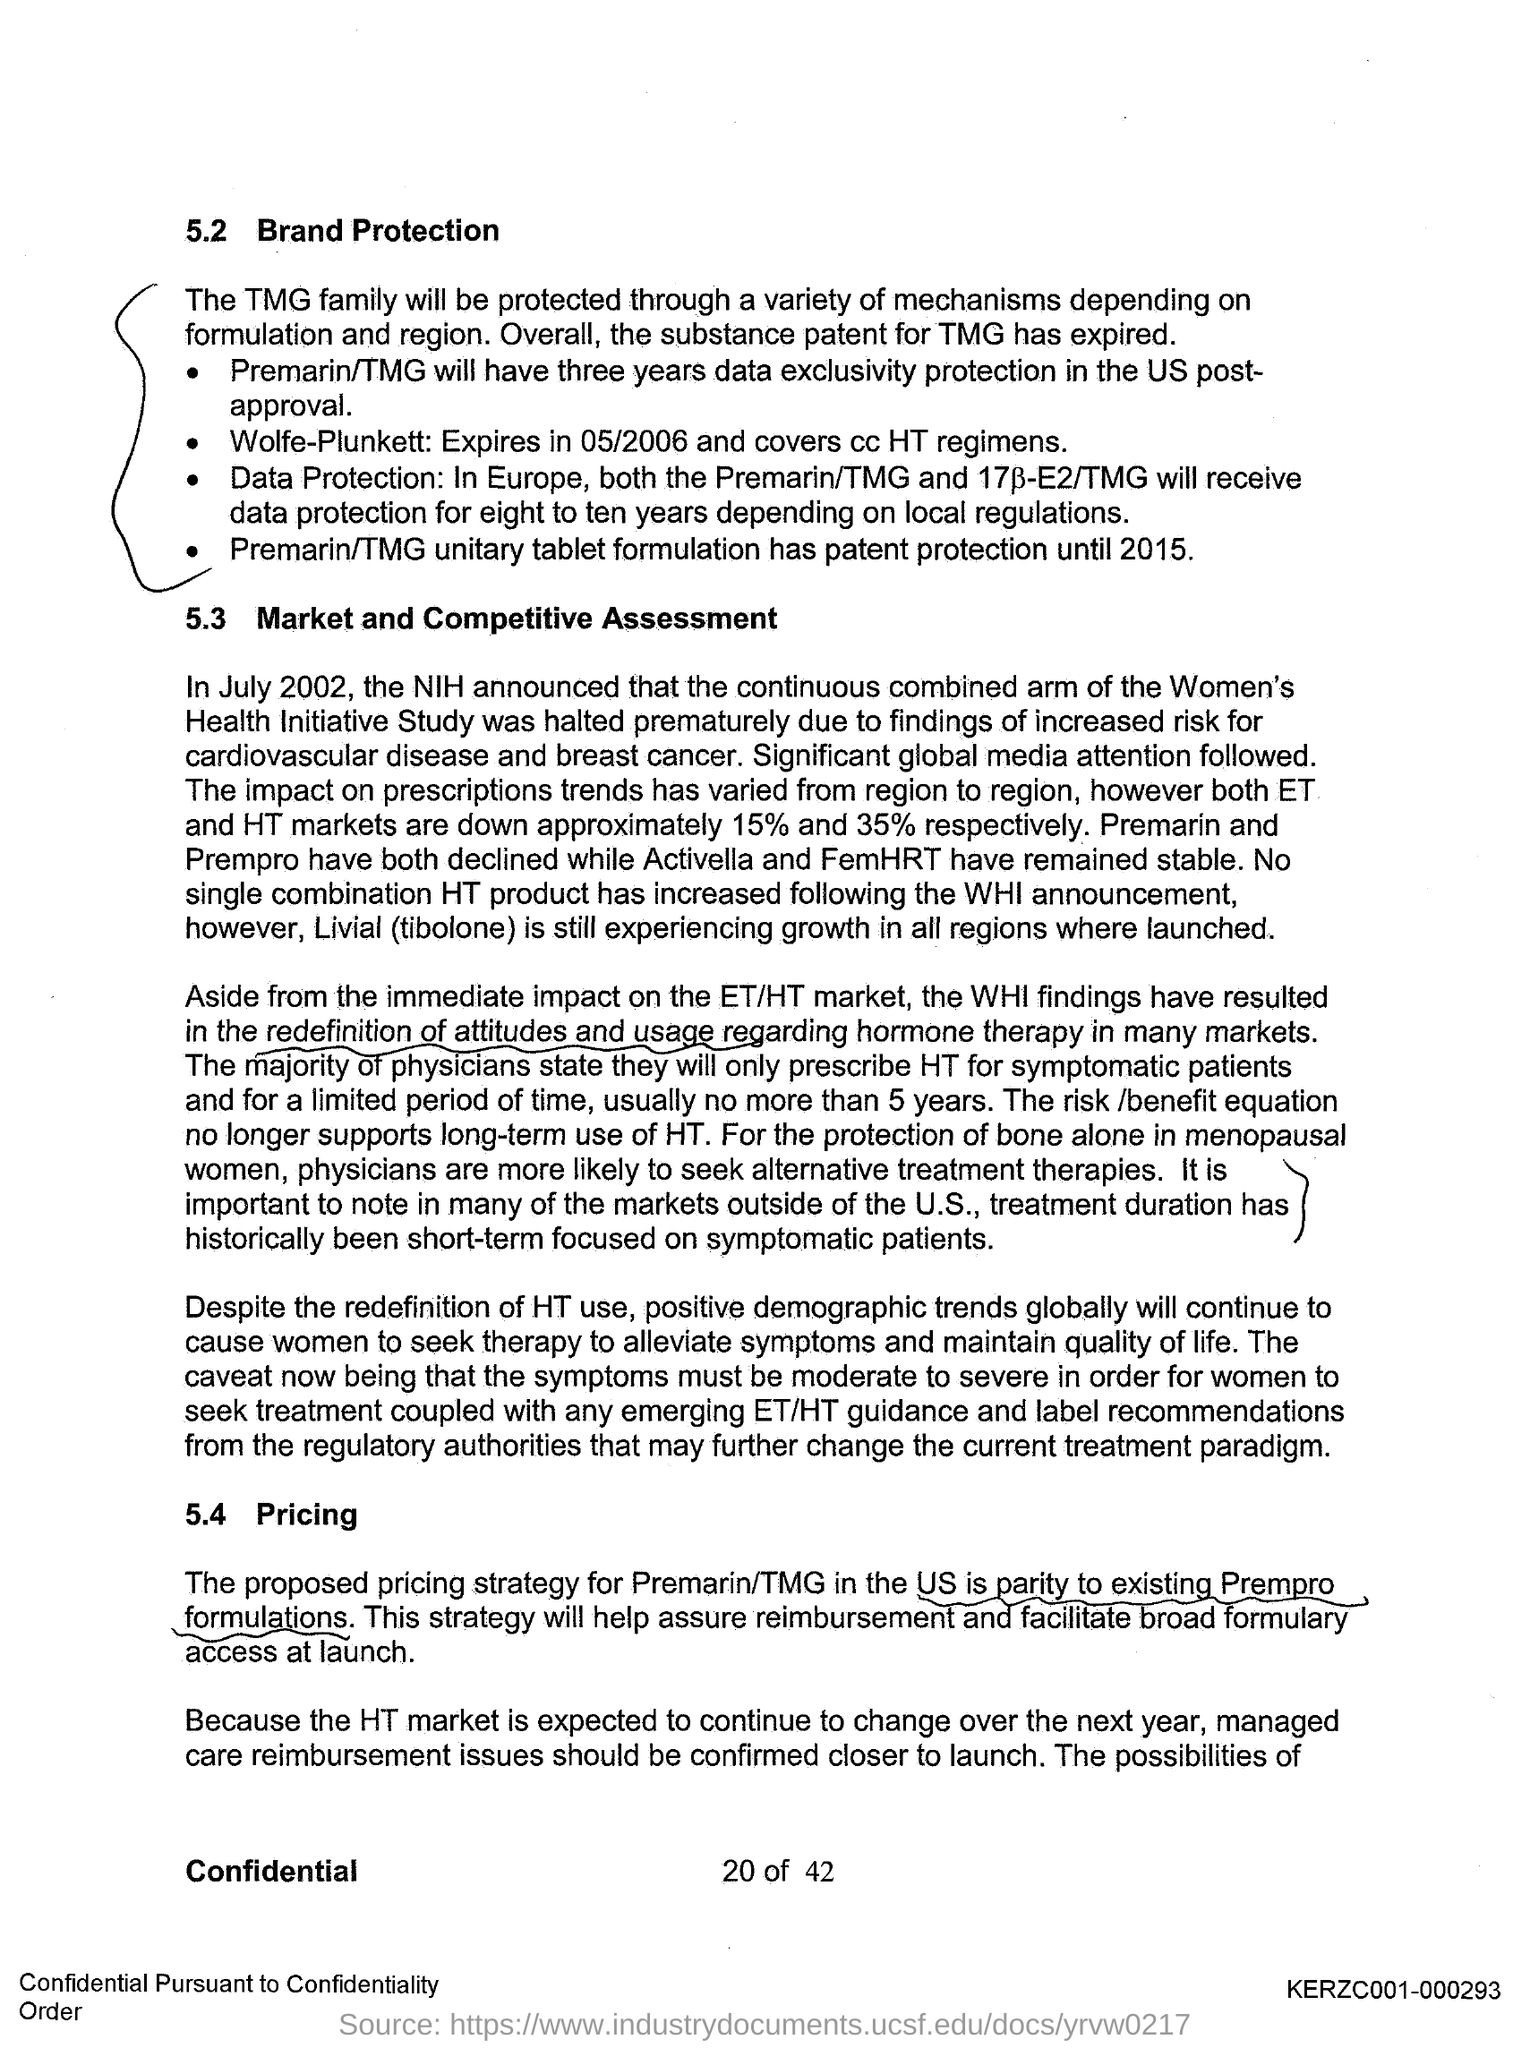Specify some key components in this picture. The document contains a title that begins with the word 'What' and another title that begins with the word '5.2.' One of these titles is 'Brand Protection.' The second title in this document is "Market and Competitive Assessment. 